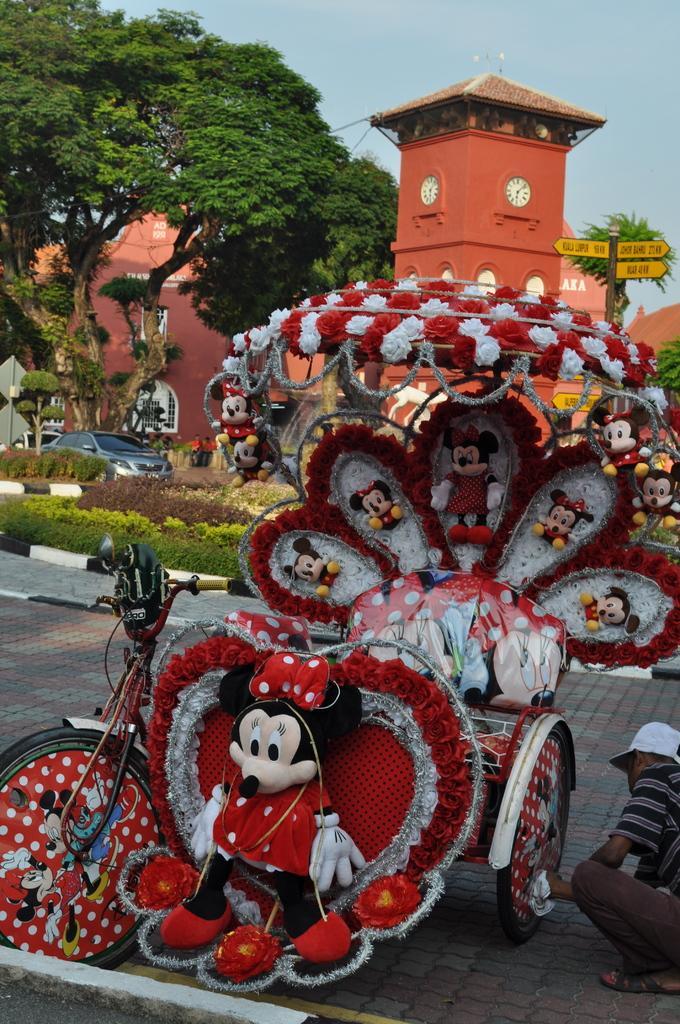How would you summarize this image in a sentence or two? In front of the picture, we see a rickshaw, which is decorated with the flowers and the stuffed toys. On the right side, we see a man who is wearing a white cap is cleaning the rickshaw. Behind that, we see the shrubs and trees. We see a car moving on the road. There are trees and buildings in the background. At the top, we see the sky. On the right side, we see the pole and the boards in yellow color with some text written. 